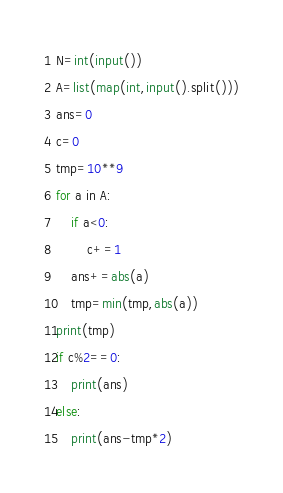Convert code to text. <code><loc_0><loc_0><loc_500><loc_500><_Python_>N=int(input())
A=list(map(int,input().split()))
ans=0
c=0
tmp=10**9
for a in A:
    if a<0:
        c+=1
    ans+=abs(a)
    tmp=min(tmp,abs(a))
print(tmp)
if c%2==0:
    print(ans)
else:
    print(ans-tmp*2)</code> 